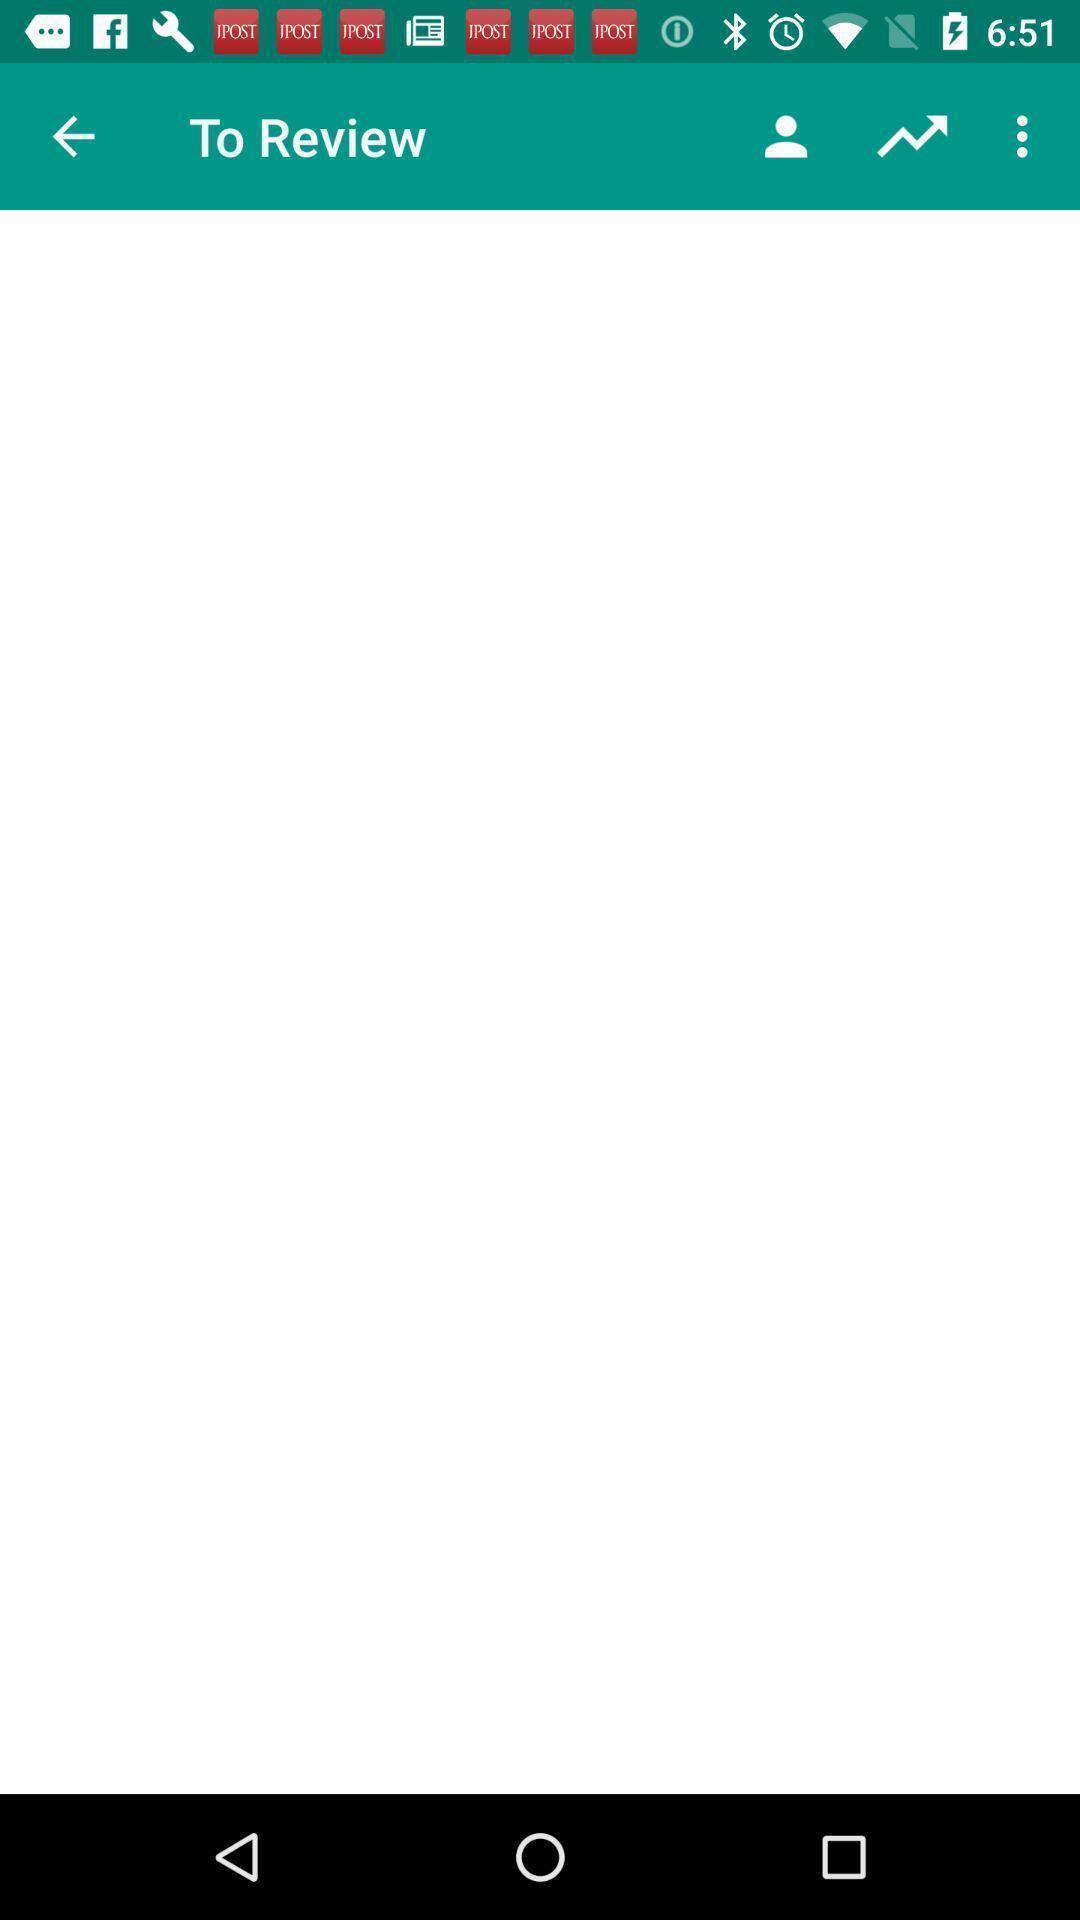Explain what's happening in this screen capture. Review page for an application. 